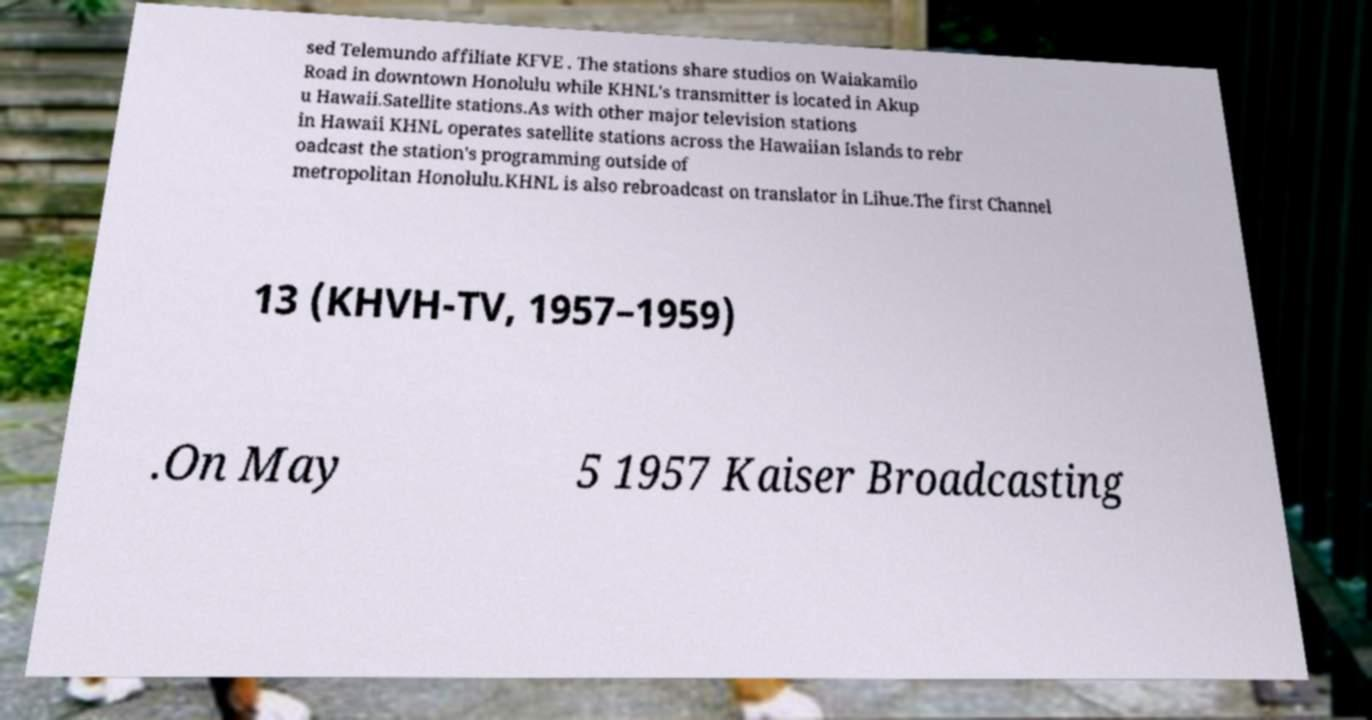What messages or text are displayed in this image? I need them in a readable, typed format. sed Telemundo affiliate KFVE . The stations share studios on Waiakamilo Road in downtown Honolulu while KHNL's transmitter is located in Akup u Hawaii.Satellite stations.As with other major television stations in Hawaii KHNL operates satellite stations across the Hawaiian Islands to rebr oadcast the station's programming outside of metropolitan Honolulu.KHNL is also rebroadcast on translator in Lihue.The first Channel 13 (KHVH-TV, 1957–1959) .On May 5 1957 Kaiser Broadcasting 